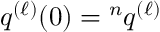<formula> <loc_0><loc_0><loc_500><loc_500>q ^ { ( \ell ) } ( 0 ) ^ { n } q ^ { ( \ell ) }</formula> 